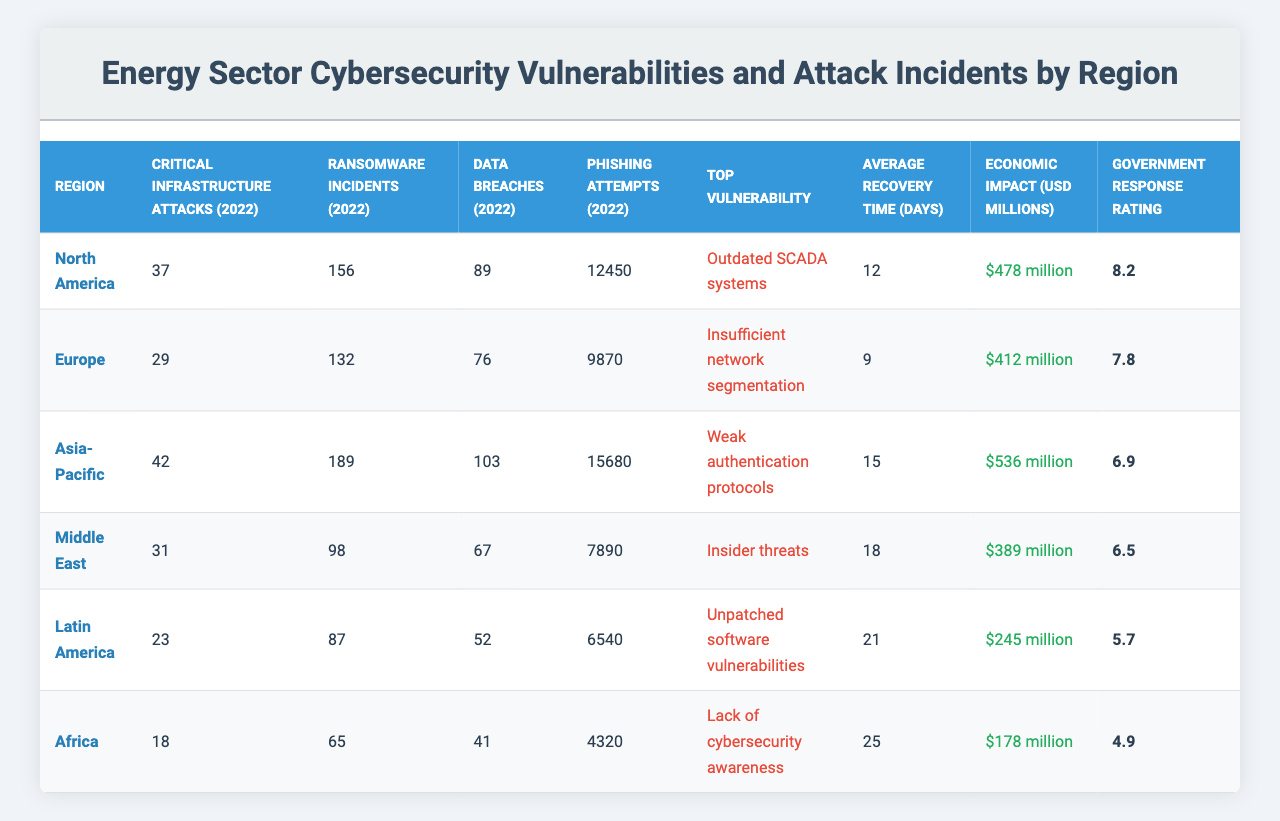What is the top vulnerability reported in North America? The table indicates that the top vulnerability in North America is "Outdated SCADA systems."
Answer: Outdated SCADA systems Which region had the highest economic impact due to cyber incidents in 2022? By comparing the economic impact values, Asia-Pacific reported the highest economic impact at $536 million.
Answer: Asia-Pacific How many ransomware incidents occurred in Europe in 2022? The table shows that Europe had 132 ransomware incidents in 2022.
Answer: 132 What is the difference in average recovery time between Africa and Latin America? Africa's average recovery time is 25 days, while Latin America's is 21 days. The difference is 25 - 21 = 4 days.
Answer: 4 days Which region experiences the most phishing attempts, based on the table? The table lists Asia-Pacific with 15,680 phishing attempts, which is higher than any other region.
Answer: Asia-Pacific Is it true that the Government Response Rating for the Middle East is higher than that of Latin America? The table shows the Middle East has a Government Response Rating of 6.5, while Latin America has a rating of 5.7, making the statement true.
Answer: Yes What is the total number of critical infrastructure attacks across all regions in 2022? The critical infrastructure attacks are 37 (North America) + 29 (Europe) + 42 (Asia-Pacific) + 31 (Middle East) + 23 (Latin America) + 18 (Africa) = 180 total attacks.
Answer: 180 Which region has the highest number of data breaches reported in 2022? The table indicates that Asia-Pacific has the highest number of data breaches with 103 reported incidents.
Answer: Asia-Pacific What is the average Government Response Rating for all regions combined? The average is calculated by summing the ratings (8.2+7.8+6.9+6.5+5.7+4.9 = 39) and dividing by the number of regions (39/6 = 6.5).
Answer: 6.5 Which region had the fewest phishing attempts in 2022? The table shows that Africa had the fewest phishing attempts with 4,320.
Answer: Africa 